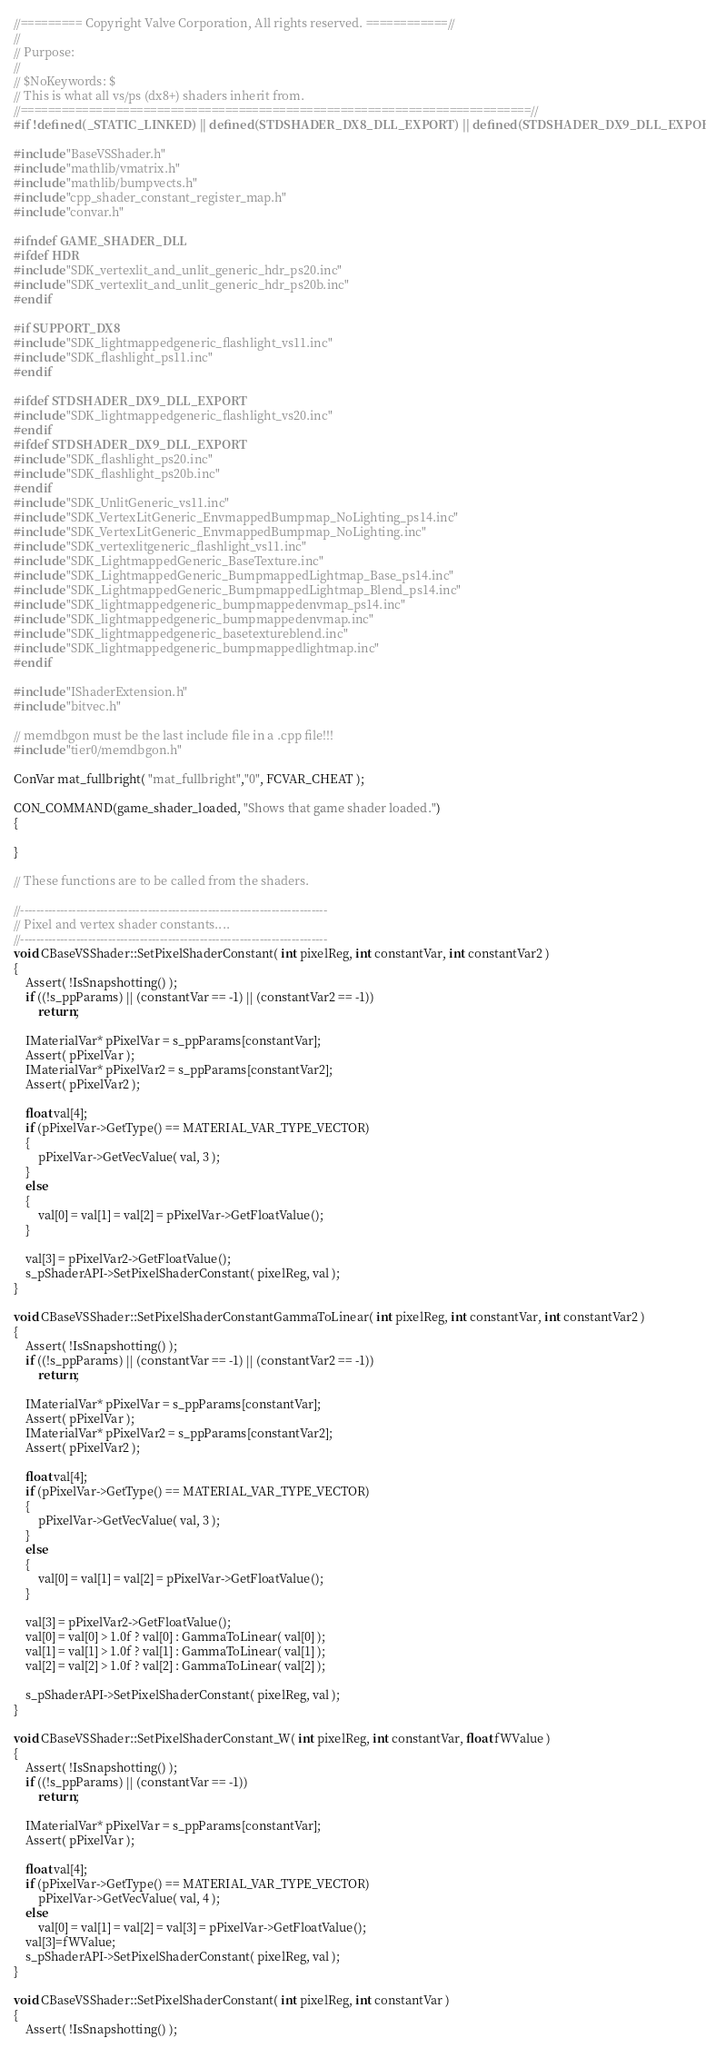Convert code to text. <code><loc_0><loc_0><loc_500><loc_500><_C++_>//========= Copyright Valve Corporation, All rights reserved. ============//
//
// Purpose: 
//
// $NoKeywords: $
// This is what all vs/ps (dx8+) shaders inherit from.
//===========================================================================//
#if !defined(_STATIC_LINKED) || defined(STDSHADER_DX8_DLL_EXPORT) || defined(STDSHADER_DX9_DLL_EXPORT)

#include "BaseVSShader.h"
#include "mathlib/vmatrix.h"
#include "mathlib/bumpvects.h"
#include "cpp_shader_constant_register_map.h"
#include "convar.h"

#ifndef GAME_SHADER_DLL
#ifdef HDR
#include "SDK_vertexlit_and_unlit_generic_hdr_ps20.inc"
#include "SDK_vertexlit_and_unlit_generic_hdr_ps20b.inc"
#endif

#if SUPPORT_DX8
#include "SDK_lightmappedgeneric_flashlight_vs11.inc"
#include "SDK_flashlight_ps11.inc"
#endif

#ifdef STDSHADER_DX9_DLL_EXPORT
#include "SDK_lightmappedgeneric_flashlight_vs20.inc"
#endif
#ifdef STDSHADER_DX9_DLL_EXPORT
#include "SDK_flashlight_ps20.inc"
#include "SDK_flashlight_ps20b.inc"
#endif
#include "SDK_UnlitGeneric_vs11.inc"
#include "SDK_VertexLitGeneric_EnvmappedBumpmap_NoLighting_ps14.inc"
#include "SDK_VertexLitGeneric_EnvmappedBumpmap_NoLighting.inc"
#include "SDK_vertexlitgeneric_flashlight_vs11.inc"
#include "SDK_LightmappedGeneric_BaseTexture.inc"
#include "SDK_LightmappedGeneric_BumpmappedLightmap_Base_ps14.inc"
#include "SDK_LightmappedGeneric_BumpmappedLightmap_Blend_ps14.inc"
#include "SDK_lightmappedgeneric_bumpmappedenvmap_ps14.inc"
#include "SDK_lightmappedgeneric_bumpmappedenvmap.inc"
#include "SDK_lightmappedgeneric_basetextureblend.inc"
#include "SDK_lightmappedgeneric_bumpmappedlightmap.inc"
#endif

#include "IShaderExtension.h"
#include "bitvec.h"

// memdbgon must be the last include file in a .cpp file!!!
#include "tier0/memdbgon.h"

ConVar mat_fullbright( "mat_fullbright","0", FCVAR_CHEAT );

CON_COMMAND(game_shader_loaded, "Shows that game shader loaded.")
{

}

// These functions are to be called from the shaders.

//-----------------------------------------------------------------------------
// Pixel and vertex shader constants....
//-----------------------------------------------------------------------------
void CBaseVSShader::SetPixelShaderConstant( int pixelReg, int constantVar, int constantVar2 )
{
	Assert( !IsSnapshotting() );
	if ((!s_ppParams) || (constantVar == -1) || (constantVar2 == -1))
		return;

	IMaterialVar* pPixelVar = s_ppParams[constantVar];
	Assert( pPixelVar );
	IMaterialVar* pPixelVar2 = s_ppParams[constantVar2];
	Assert( pPixelVar2 );

	float val[4];
	if (pPixelVar->GetType() == MATERIAL_VAR_TYPE_VECTOR)
	{
		pPixelVar->GetVecValue( val, 3 );
	}
	else
	{
		val[0] = val[1] = val[2] = pPixelVar->GetFloatValue();
	}

	val[3] = pPixelVar2->GetFloatValue();
	s_pShaderAPI->SetPixelShaderConstant( pixelReg, val );	
}

void CBaseVSShader::SetPixelShaderConstantGammaToLinear( int pixelReg, int constantVar, int constantVar2 )
{
	Assert( !IsSnapshotting() );
	if ((!s_ppParams) || (constantVar == -1) || (constantVar2 == -1))
		return;

	IMaterialVar* pPixelVar = s_ppParams[constantVar];
	Assert( pPixelVar );
	IMaterialVar* pPixelVar2 = s_ppParams[constantVar2];
	Assert( pPixelVar2 );

	float val[4];
	if (pPixelVar->GetType() == MATERIAL_VAR_TYPE_VECTOR)
	{
		pPixelVar->GetVecValue( val, 3 );
	}
	else
	{
		val[0] = val[1] = val[2] = pPixelVar->GetFloatValue();
	}

	val[3] = pPixelVar2->GetFloatValue();
	val[0] = val[0] > 1.0f ? val[0] : GammaToLinear( val[0] );
	val[1] = val[1] > 1.0f ? val[1] : GammaToLinear( val[1] );
	val[2] = val[2] > 1.0f ? val[2] : GammaToLinear( val[2] );

	s_pShaderAPI->SetPixelShaderConstant( pixelReg, val );	
}

void CBaseVSShader::SetPixelShaderConstant_W( int pixelReg, int constantVar, float fWValue )
{
	Assert( !IsSnapshotting() );
	if ((!s_ppParams) || (constantVar == -1))
		return;

	IMaterialVar* pPixelVar = s_ppParams[constantVar];
	Assert( pPixelVar );

	float val[4];
	if (pPixelVar->GetType() == MATERIAL_VAR_TYPE_VECTOR)
		pPixelVar->GetVecValue( val, 4 );
	else
		val[0] = val[1] = val[2] = val[3] = pPixelVar->GetFloatValue();
	val[3]=fWValue;
	s_pShaderAPI->SetPixelShaderConstant( pixelReg, val );	
}

void CBaseVSShader::SetPixelShaderConstant( int pixelReg, int constantVar )
{
	Assert( !IsSnapshotting() );</code> 